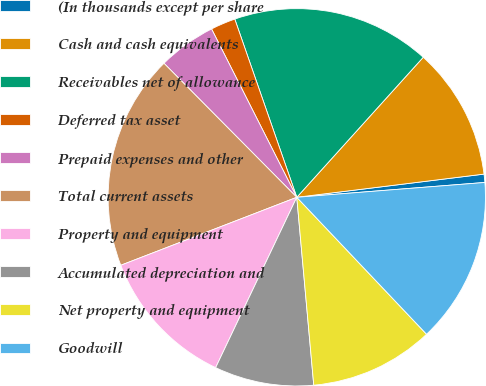Convert chart. <chart><loc_0><loc_0><loc_500><loc_500><pie_chart><fcel>(In thousands except per share<fcel>Cash and cash equivalents<fcel>Receivables net of allowance<fcel>Deferred tax asset<fcel>Prepaid expenses and other<fcel>Total current assets<fcel>Property and equipment<fcel>Accumulated depreciation and<fcel>Net property and equipment<fcel>Goodwill<nl><fcel>0.71%<fcel>11.35%<fcel>17.02%<fcel>2.13%<fcel>4.97%<fcel>18.44%<fcel>12.06%<fcel>8.51%<fcel>10.64%<fcel>14.18%<nl></chart> 